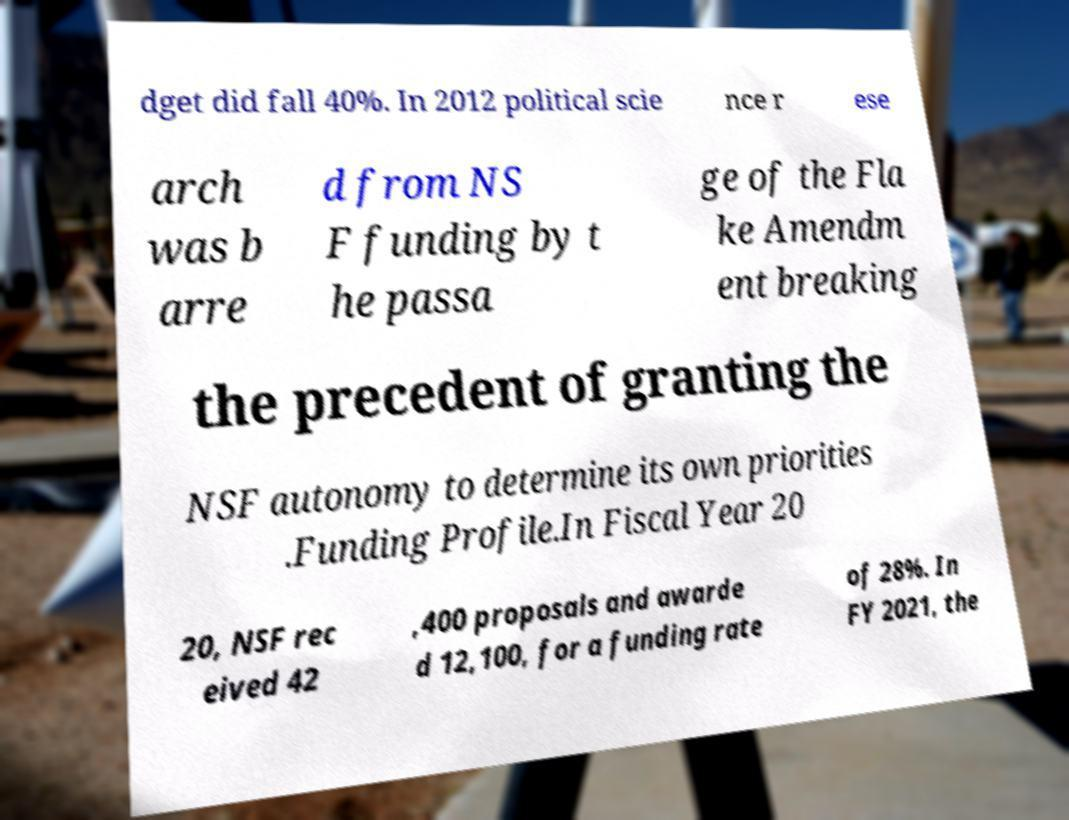For documentation purposes, I need the text within this image transcribed. Could you provide that? dget did fall 40%. In 2012 political scie nce r ese arch was b arre d from NS F funding by t he passa ge of the Fla ke Amendm ent breaking the precedent of granting the NSF autonomy to determine its own priorities .Funding Profile.In Fiscal Year 20 20, NSF rec eived 42 ,400 proposals and awarde d 12,100, for a funding rate of 28%. In FY 2021, the 